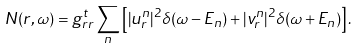<formula> <loc_0><loc_0><loc_500><loc_500>N ( r , \omega ) = g ^ { t } _ { r r } \sum _ { n } \left [ | u _ { r } ^ { n } | ^ { 2 } \delta ( \omega - E _ { n } ) + | v _ { r } ^ { n } | ^ { 2 } \delta ( \omega + E _ { n } ) \right ] .</formula> 